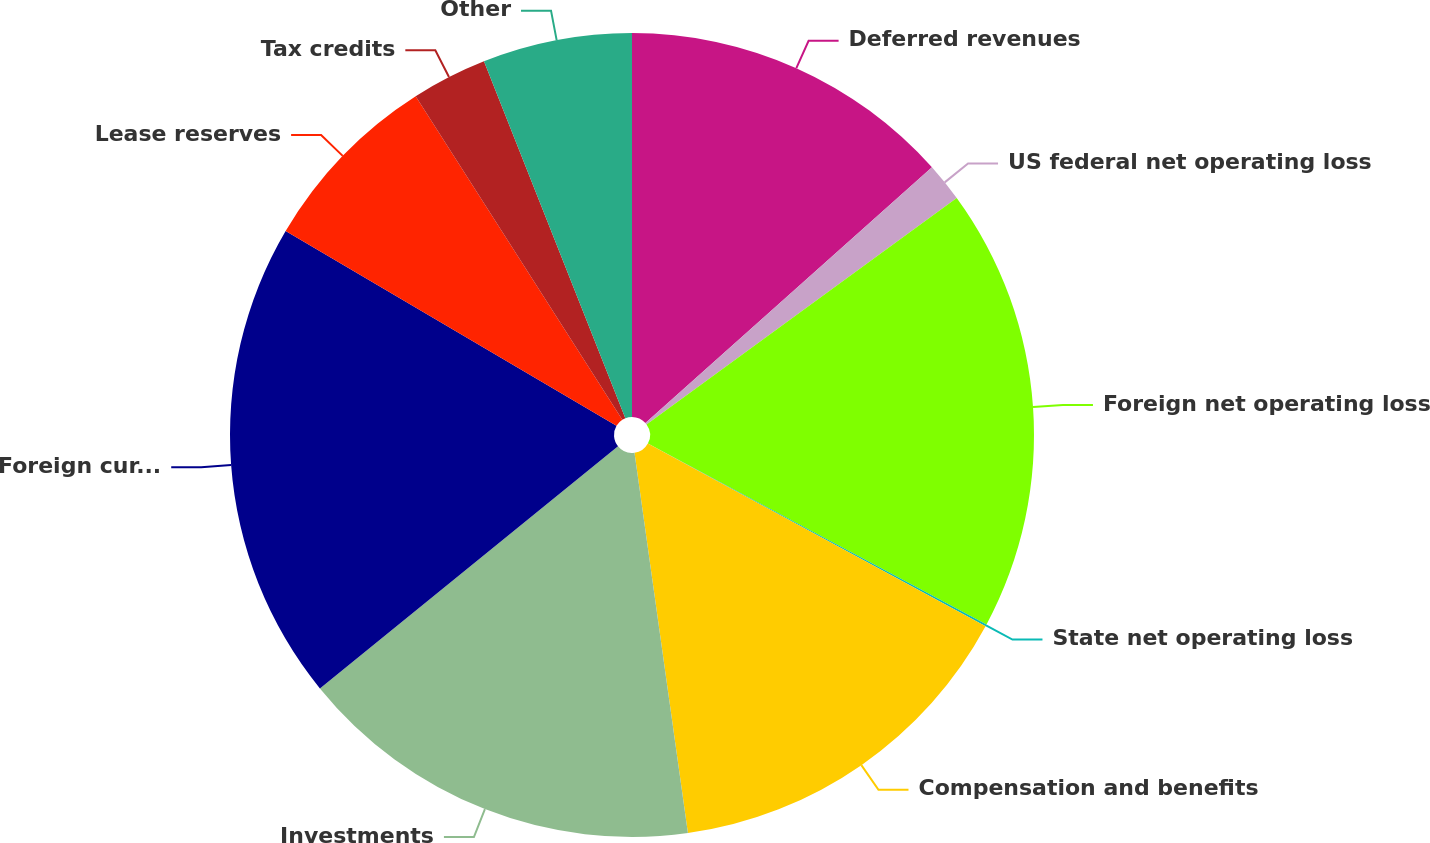<chart> <loc_0><loc_0><loc_500><loc_500><pie_chart><fcel>Deferred revenues<fcel>US federal net operating loss<fcel>Foreign net operating loss<fcel>State net operating loss<fcel>Compensation and benefits<fcel>Investments<fcel>Foreign currency translation<fcel>Lease reserves<fcel>Tax credits<fcel>Other<nl><fcel>13.4%<fcel>1.56%<fcel>17.84%<fcel>0.08%<fcel>14.88%<fcel>16.36%<fcel>19.32%<fcel>7.48%<fcel>3.04%<fcel>6.0%<nl></chart> 